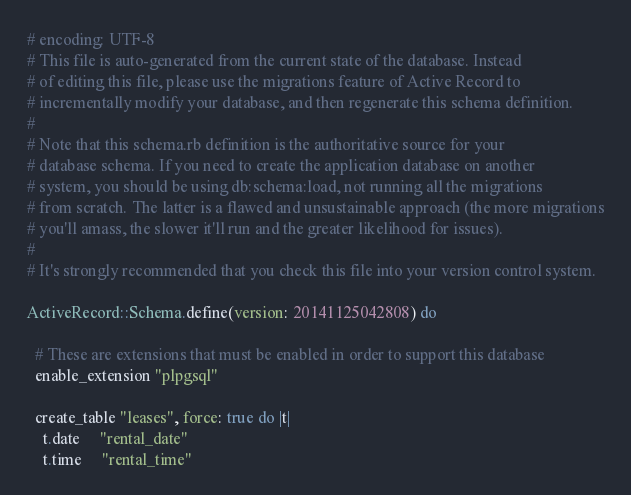Convert code to text. <code><loc_0><loc_0><loc_500><loc_500><_Ruby_># encoding: UTF-8
# This file is auto-generated from the current state of the database. Instead
# of editing this file, please use the migrations feature of Active Record to
# incrementally modify your database, and then regenerate this schema definition.
#
# Note that this schema.rb definition is the authoritative source for your
# database schema. If you need to create the application database on another
# system, you should be using db:schema:load, not running all the migrations
# from scratch. The latter is a flawed and unsustainable approach (the more migrations
# you'll amass, the slower it'll run and the greater likelihood for issues).
#
# It's strongly recommended that you check this file into your version control system.

ActiveRecord::Schema.define(version: 20141125042808) do

  # These are extensions that must be enabled in order to support this database
  enable_extension "plpgsql"

  create_table "leases", force: true do |t|
    t.date     "rental_date"
    t.time     "rental_time"</code> 